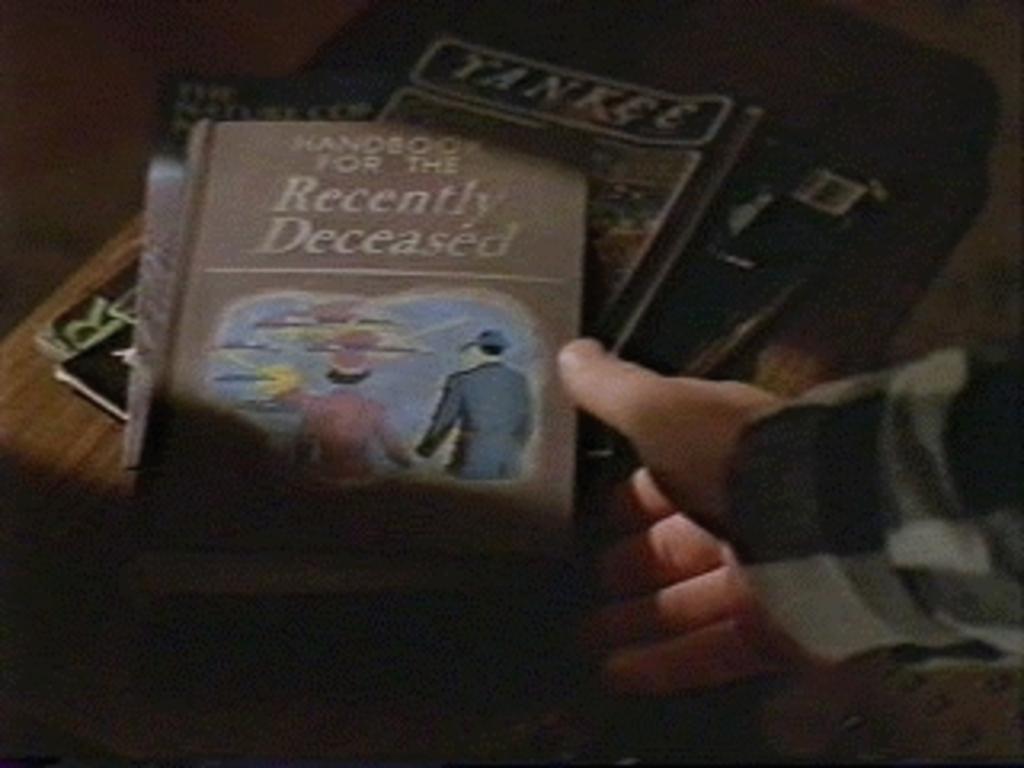In one or two sentences, can you explain what this image depicts? In this image I can see some books on a table and a person's hand.  